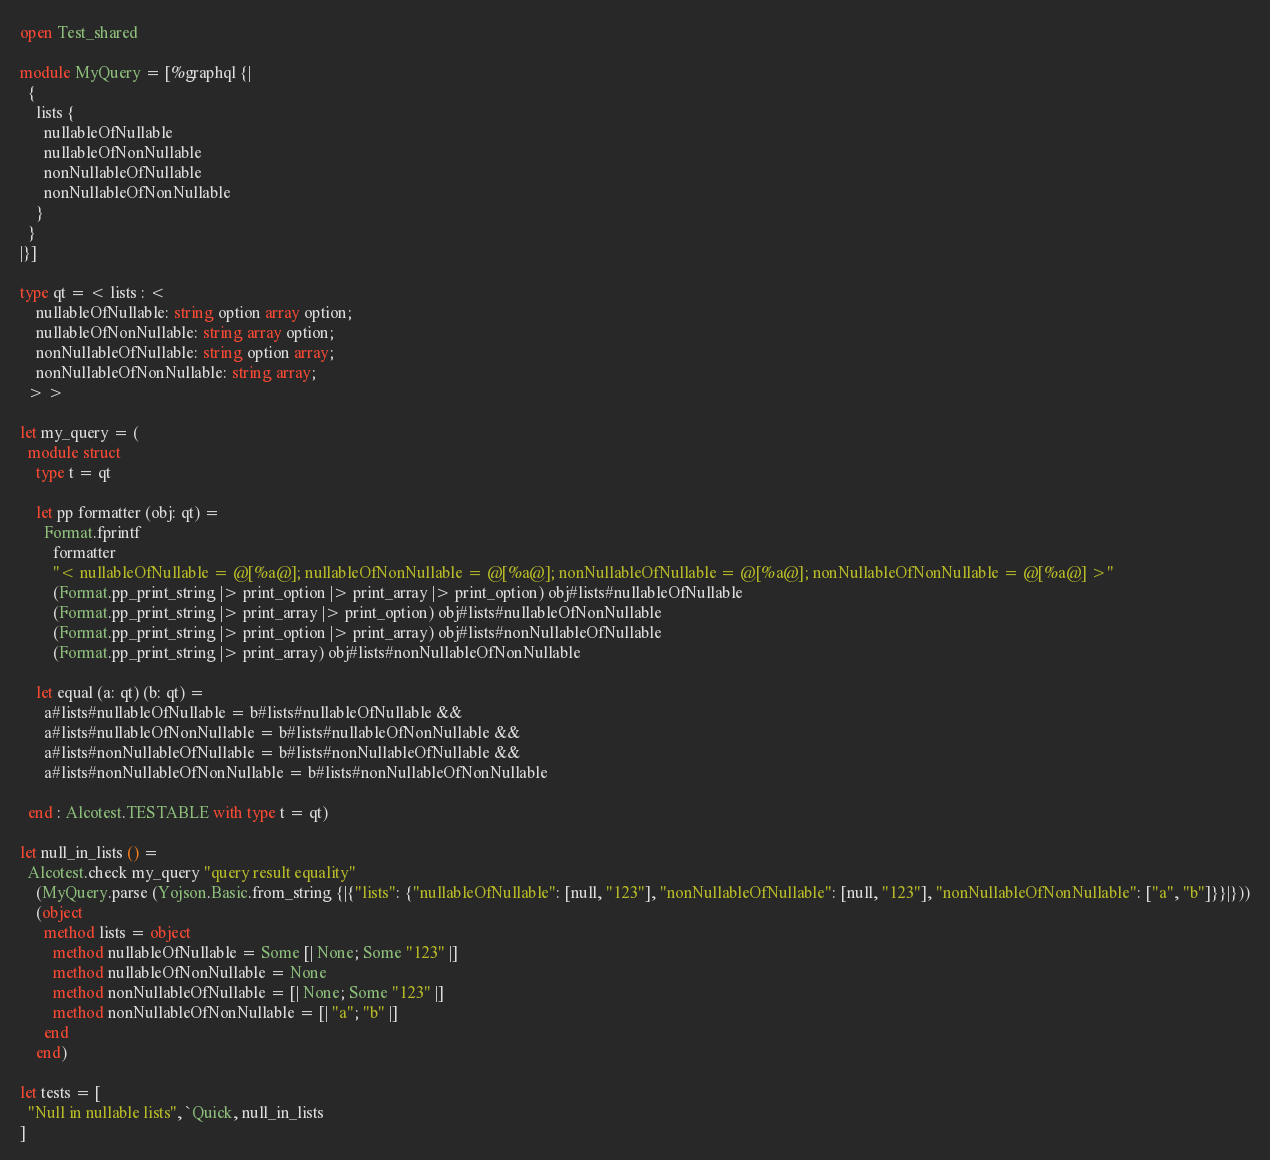<code> <loc_0><loc_0><loc_500><loc_500><_OCaml_>open Test_shared

module MyQuery = [%graphql {|
  {
    lists {
      nullableOfNullable
      nullableOfNonNullable
      nonNullableOfNullable
      nonNullableOfNonNullable
    }
  }
|}]

type qt = < lists : <
    nullableOfNullable: string option array option;
    nullableOfNonNullable: string array option;
    nonNullableOfNullable: string option array;
    nonNullableOfNonNullable: string array;
  > >

let my_query = (
  module struct
    type t = qt

    let pp formatter (obj: qt) =
      Format.fprintf
        formatter
        "< nullableOfNullable = @[%a@]; nullableOfNonNullable = @[%a@]; nonNullableOfNullable = @[%a@]; nonNullableOfNonNullable = @[%a@] >"
        (Format.pp_print_string |> print_option |> print_array |> print_option) obj#lists#nullableOfNullable
        (Format.pp_print_string |> print_array |> print_option) obj#lists#nullableOfNonNullable
        (Format.pp_print_string |> print_option |> print_array) obj#lists#nonNullableOfNullable
        (Format.pp_print_string |> print_array) obj#lists#nonNullableOfNonNullable

    let equal (a: qt) (b: qt) =
      a#lists#nullableOfNullable = b#lists#nullableOfNullable &&
      a#lists#nullableOfNonNullable = b#lists#nullableOfNonNullable &&
      a#lists#nonNullableOfNullable = b#lists#nonNullableOfNullable &&
      a#lists#nonNullableOfNonNullable = b#lists#nonNullableOfNonNullable

  end : Alcotest.TESTABLE with type t = qt)

let null_in_lists () =
  Alcotest.check my_query "query result equality"
    (MyQuery.parse (Yojson.Basic.from_string {|{"lists": {"nullableOfNullable": [null, "123"], "nonNullableOfNullable": [null, "123"], "nonNullableOfNonNullable": ["a", "b"]}}|}))
    (object
      method lists = object
        method nullableOfNullable = Some [| None; Some "123" |]
        method nullableOfNonNullable = None
        method nonNullableOfNullable = [| None; Some "123" |]
        method nonNullableOfNonNullable = [| "a"; "b" |]
      end
    end)

let tests = [
  "Null in nullable lists", `Quick, null_in_lists
]
</code> 